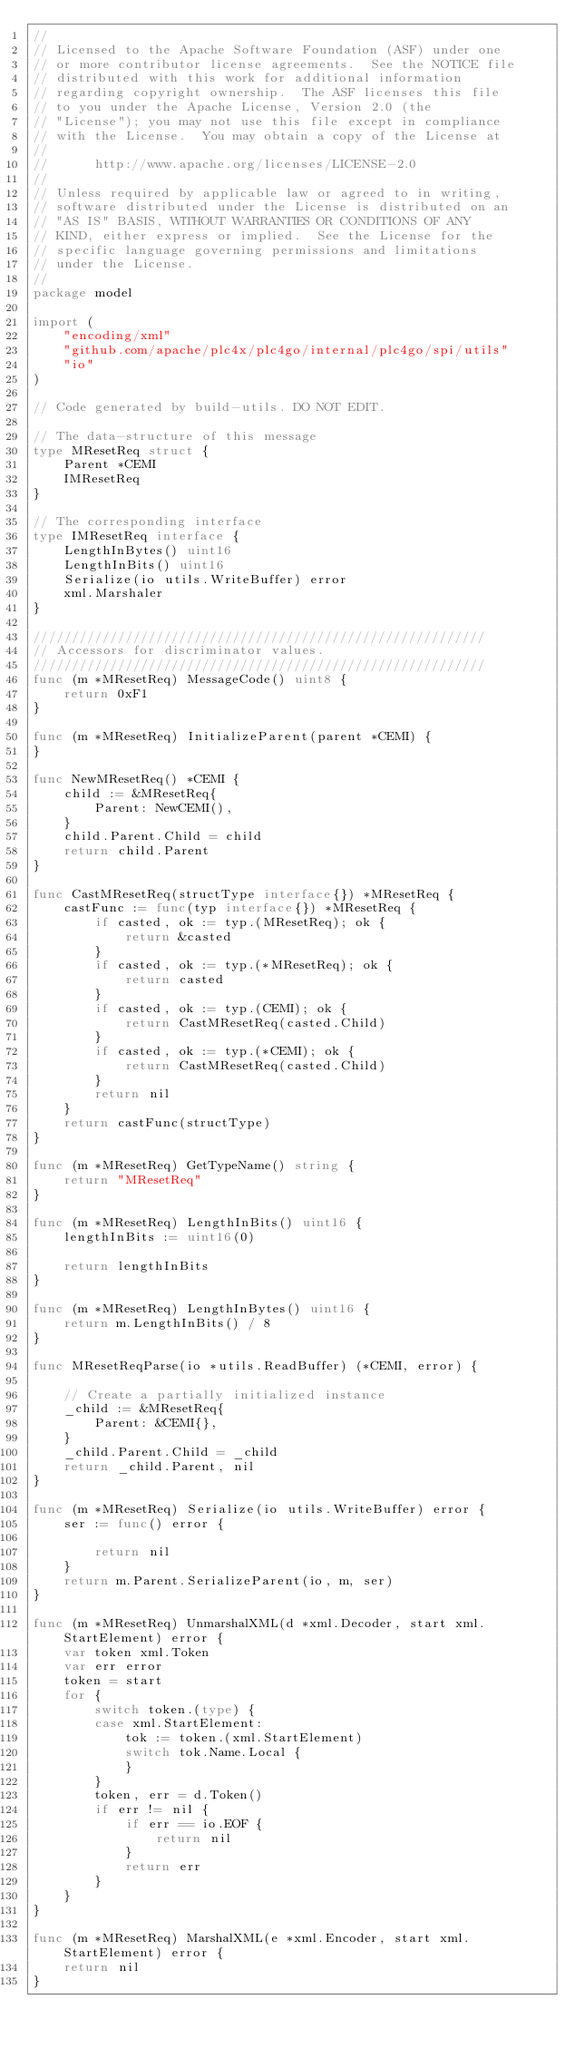<code> <loc_0><loc_0><loc_500><loc_500><_Go_>//
// Licensed to the Apache Software Foundation (ASF) under one
// or more contributor license agreements.  See the NOTICE file
// distributed with this work for additional information
// regarding copyright ownership.  The ASF licenses this file
// to you under the Apache License, Version 2.0 (the
// "License"); you may not use this file except in compliance
// with the License.  You may obtain a copy of the License at
//
//      http://www.apache.org/licenses/LICENSE-2.0
//
// Unless required by applicable law or agreed to in writing,
// software distributed under the License is distributed on an
// "AS IS" BASIS, WITHOUT WARRANTIES OR CONDITIONS OF ANY
// KIND, either express or implied.  See the License for the
// specific language governing permissions and limitations
// under the License.
//
package model

import (
	"encoding/xml"
	"github.com/apache/plc4x/plc4go/internal/plc4go/spi/utils"
	"io"
)

// Code generated by build-utils. DO NOT EDIT.

// The data-structure of this message
type MResetReq struct {
	Parent *CEMI
	IMResetReq
}

// The corresponding interface
type IMResetReq interface {
	LengthInBytes() uint16
	LengthInBits() uint16
	Serialize(io utils.WriteBuffer) error
	xml.Marshaler
}

///////////////////////////////////////////////////////////
// Accessors for discriminator values.
///////////////////////////////////////////////////////////
func (m *MResetReq) MessageCode() uint8 {
	return 0xF1
}

func (m *MResetReq) InitializeParent(parent *CEMI) {
}

func NewMResetReq() *CEMI {
	child := &MResetReq{
		Parent: NewCEMI(),
	}
	child.Parent.Child = child
	return child.Parent
}

func CastMResetReq(structType interface{}) *MResetReq {
	castFunc := func(typ interface{}) *MResetReq {
		if casted, ok := typ.(MResetReq); ok {
			return &casted
		}
		if casted, ok := typ.(*MResetReq); ok {
			return casted
		}
		if casted, ok := typ.(CEMI); ok {
			return CastMResetReq(casted.Child)
		}
		if casted, ok := typ.(*CEMI); ok {
			return CastMResetReq(casted.Child)
		}
		return nil
	}
	return castFunc(structType)
}

func (m *MResetReq) GetTypeName() string {
	return "MResetReq"
}

func (m *MResetReq) LengthInBits() uint16 {
	lengthInBits := uint16(0)

	return lengthInBits
}

func (m *MResetReq) LengthInBytes() uint16 {
	return m.LengthInBits() / 8
}

func MResetReqParse(io *utils.ReadBuffer) (*CEMI, error) {

	// Create a partially initialized instance
	_child := &MResetReq{
		Parent: &CEMI{},
	}
	_child.Parent.Child = _child
	return _child.Parent, nil
}

func (m *MResetReq) Serialize(io utils.WriteBuffer) error {
	ser := func() error {

		return nil
	}
	return m.Parent.SerializeParent(io, m, ser)
}

func (m *MResetReq) UnmarshalXML(d *xml.Decoder, start xml.StartElement) error {
	var token xml.Token
	var err error
	token = start
	for {
		switch token.(type) {
		case xml.StartElement:
			tok := token.(xml.StartElement)
			switch tok.Name.Local {
			}
		}
		token, err = d.Token()
		if err != nil {
			if err == io.EOF {
				return nil
			}
			return err
		}
	}
}

func (m *MResetReq) MarshalXML(e *xml.Encoder, start xml.StartElement) error {
	return nil
}
</code> 